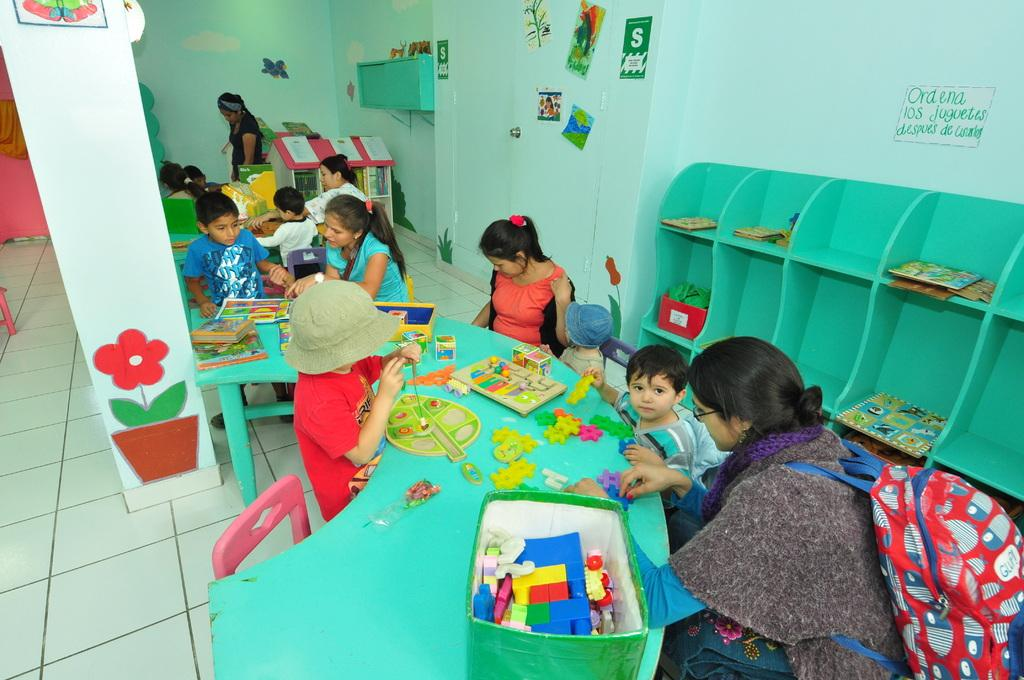What type of structure can be seen in the image? There is a wall in the image. Who or what is present in the image? There are people in the image. What type of furniture is visible in the image? Chairs and tables are present in the image. What objects are on the table in the image? There are building boxes and posters on a table. What advice does the grandmother give to the people in the image during their journey? There is no grandmother or journey present in the image. 